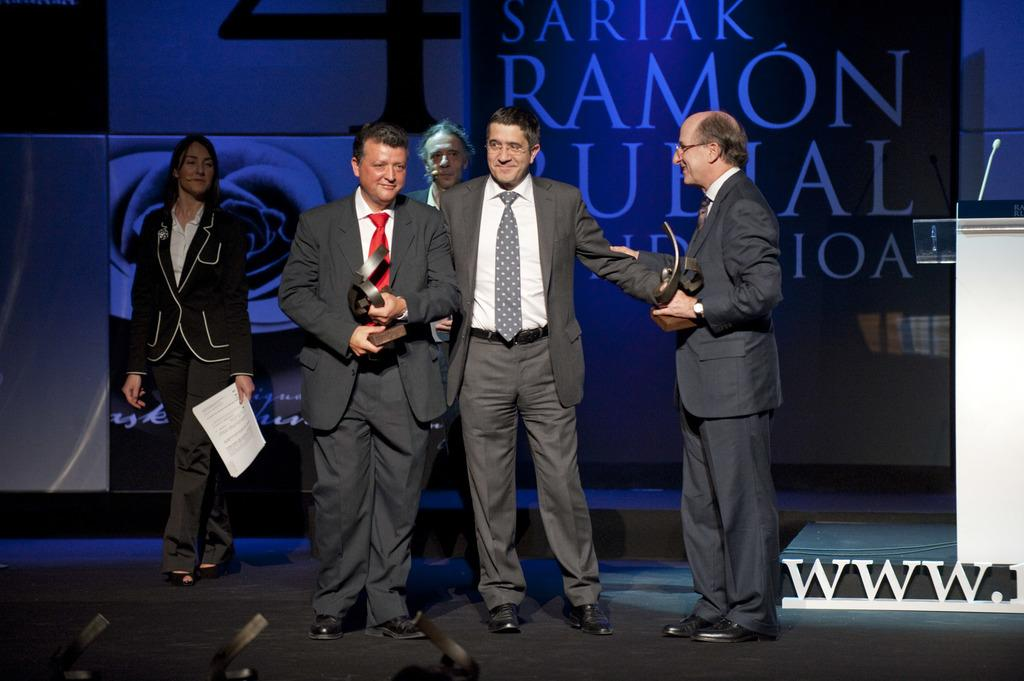What are the people in the image doing with an object? The people in the image are holding an object. What structure can be seen in the image? There is a podium in the image. What is written or displayed on a surface in the image? There is a board with text in the image. How many frogs are jumping on the podium in the image? There are no frogs present in the image; the podium is empty. Can you describe the quiver used by the people holding the object in the image? There is no mention of a quiver in the image; the people are simply holding an object. 